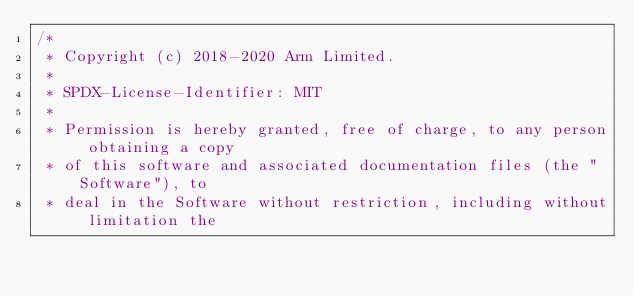<code> <loc_0><loc_0><loc_500><loc_500><_C_>/*
 * Copyright (c) 2018-2020 Arm Limited.
 *
 * SPDX-License-Identifier: MIT
 *
 * Permission is hereby granted, free of charge, to any person obtaining a copy
 * of this software and associated documentation files (the "Software"), to
 * deal in the Software without restriction, including without limitation the</code> 